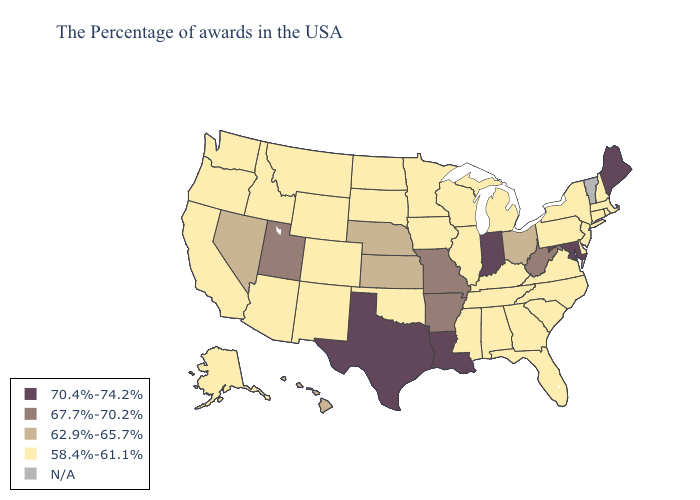Among the states that border Arizona , does New Mexico have the highest value?
Keep it brief. No. Does New Jersey have the highest value in the USA?
Give a very brief answer. No. Name the states that have a value in the range 70.4%-74.2%?
Quick response, please. Maine, Maryland, Indiana, Louisiana, Texas. Name the states that have a value in the range N/A?
Write a very short answer. Vermont. What is the value of Virginia?
Concise answer only. 58.4%-61.1%. What is the value of Kansas?
Keep it brief. 62.9%-65.7%. Which states hav the highest value in the MidWest?
Quick response, please. Indiana. Name the states that have a value in the range 58.4%-61.1%?
Keep it brief. Massachusetts, Rhode Island, New Hampshire, Connecticut, New York, New Jersey, Delaware, Pennsylvania, Virginia, North Carolina, South Carolina, Florida, Georgia, Michigan, Kentucky, Alabama, Tennessee, Wisconsin, Illinois, Mississippi, Minnesota, Iowa, Oklahoma, South Dakota, North Dakota, Wyoming, Colorado, New Mexico, Montana, Arizona, Idaho, California, Washington, Oregon, Alaska. Among the states that border South Dakota , does Nebraska have the lowest value?
Short answer required. No. Name the states that have a value in the range 58.4%-61.1%?
Concise answer only. Massachusetts, Rhode Island, New Hampshire, Connecticut, New York, New Jersey, Delaware, Pennsylvania, Virginia, North Carolina, South Carolina, Florida, Georgia, Michigan, Kentucky, Alabama, Tennessee, Wisconsin, Illinois, Mississippi, Minnesota, Iowa, Oklahoma, South Dakota, North Dakota, Wyoming, Colorado, New Mexico, Montana, Arizona, Idaho, California, Washington, Oregon, Alaska. Among the states that border Illinois , does Wisconsin have the lowest value?
Concise answer only. Yes. Does the map have missing data?
Quick response, please. Yes. What is the value of Missouri?
Keep it brief. 67.7%-70.2%. How many symbols are there in the legend?
Concise answer only. 5. 